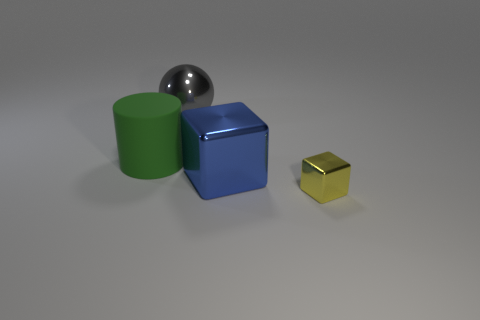What number of green metallic spheres have the same size as the blue thing?
Give a very brief answer. 0. There is a big thing behind the green thing; what is its shape?
Your answer should be very brief. Sphere. Are there fewer large metal objects than metal spheres?
Make the answer very short. No. Are there any other things that are the same color as the large matte cylinder?
Provide a succinct answer. No. What size is the shiny object behind the large green cylinder?
Your response must be concise. Large. Is the number of yellow metal objects greater than the number of metal blocks?
Ensure brevity in your answer.  No. What material is the large green thing?
Provide a short and direct response. Rubber. What number of other things are there of the same material as the cylinder
Your answer should be compact. 0. How many big matte cylinders are there?
Keep it short and to the point. 1. What is the material of the other tiny thing that is the same shape as the blue object?
Offer a very short reply. Metal. 